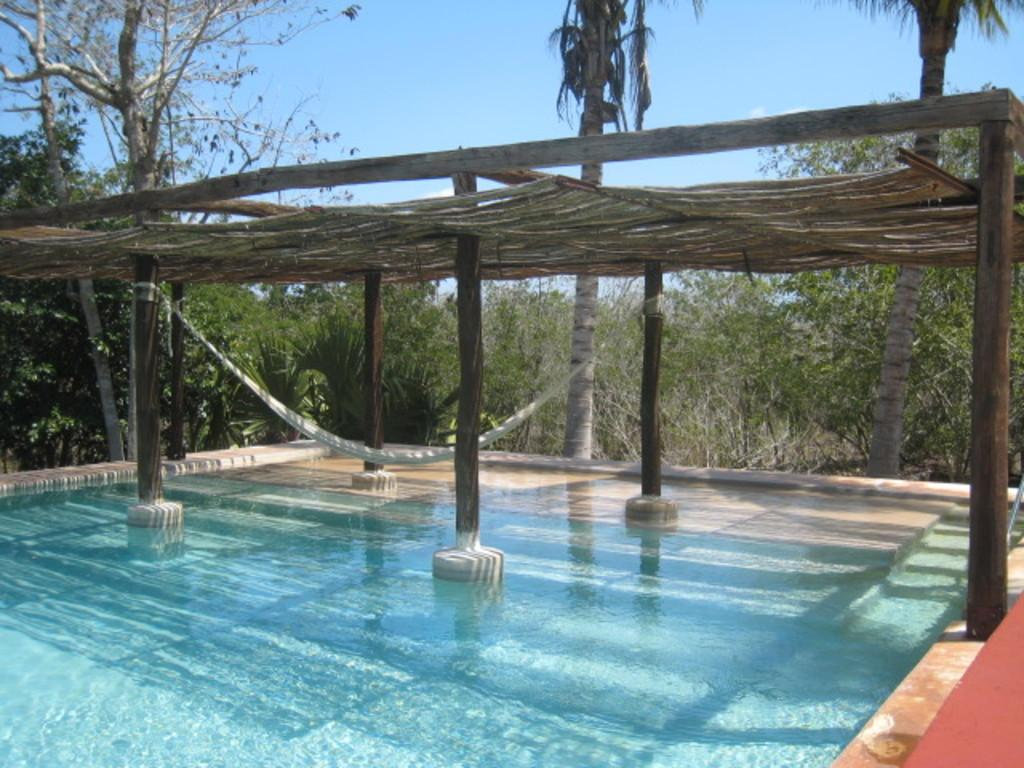What is the primary element visible in the image? There is water in the image. What structures can be seen in the image? There are wooden poles and a roof visible in the image. What can be seen in the background of the image? There are trees and clouds in the sky in the background of the image. Where is the key located in the image? There is no key present in the image. What type of lift can be seen in the image? There is no lift present in the image. 